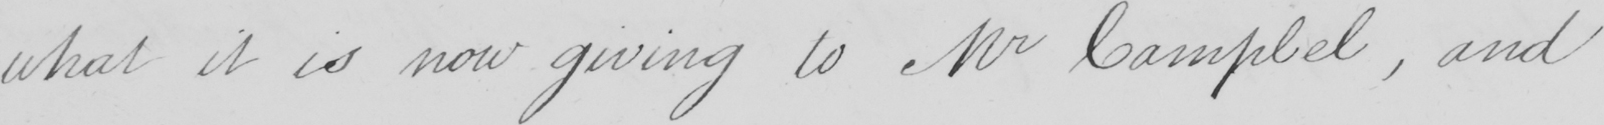Can you tell me what this handwritten text says? what it is now giving to Mr Campbell , and 